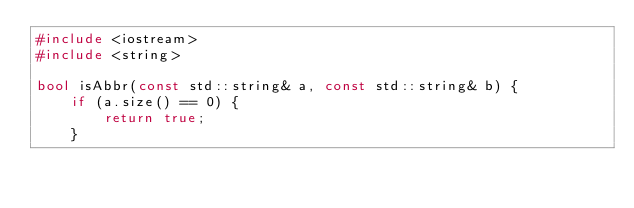Convert code to text. <code><loc_0><loc_0><loc_500><loc_500><_C++_>#include <iostream>
#include <string>

bool isAbbr(const std::string& a, const std::string& b) {
    if (a.size() == 0) {
        return true;
    }</code> 